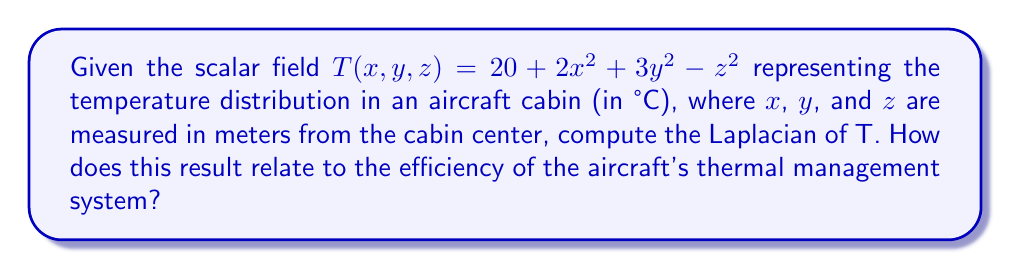Give your solution to this math problem. To solve this problem, we'll follow these steps:

1) Recall that the Laplacian of a scalar field in 3D Cartesian coordinates is given by:

   $$\nabla^2 T = \frac{\partial^2 T}{\partial x^2} + \frac{\partial^2 T}{\partial y^2} + \frac{\partial^2 T}{\partial z^2}$$

2) Let's calculate each second partial derivative:

   $\frac{\partial T}{\partial x} = 4x$
   $\frac{\partial^2 T}{\partial x^2} = 4$

   $\frac{\partial T}{\partial y} = 6y$
   $\frac{\partial^2 T}{\partial y^2} = 6$

   $\frac{\partial T}{\partial z} = -2z$
   $\frac{\partial^2 T}{\partial z^2} = -2$

3) Now, we can substitute these values into the Laplacian formula:

   $$\nabla^2 T = 4 + 6 + (-2) = 8$$

4) Interpretation: The positive Laplacian indicates that, on average, the temperature at any point is lower than the average temperature of its surrounding points. This suggests that heat is flowing into most points in the cabin from their surroundings.

5) For aircraft efficiency: A positive Laplacian implies that the thermal management system might be overcooling the cabin center. This could lead to increased energy consumption and reduced fuel efficiency. An ideal system would maintain a more uniform temperature distribution, resulting in a Laplacian closer to zero.
Answer: $\nabla^2 T = 8$ °C/m² 